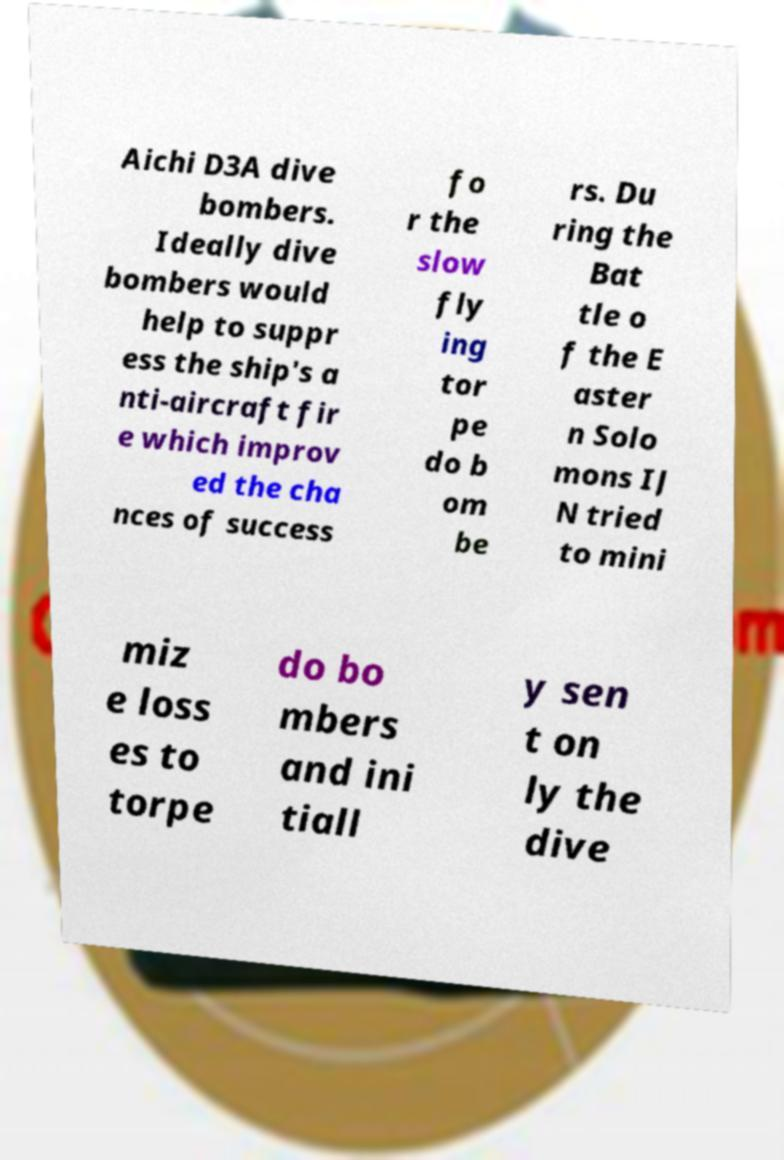What messages or text are displayed in this image? I need them in a readable, typed format. Aichi D3A dive bombers. Ideally dive bombers would help to suppr ess the ship's a nti-aircraft fir e which improv ed the cha nces of success fo r the slow fly ing tor pe do b om be rs. Du ring the Bat tle o f the E aster n Solo mons IJ N tried to mini miz e loss es to torpe do bo mbers and ini tiall y sen t on ly the dive 